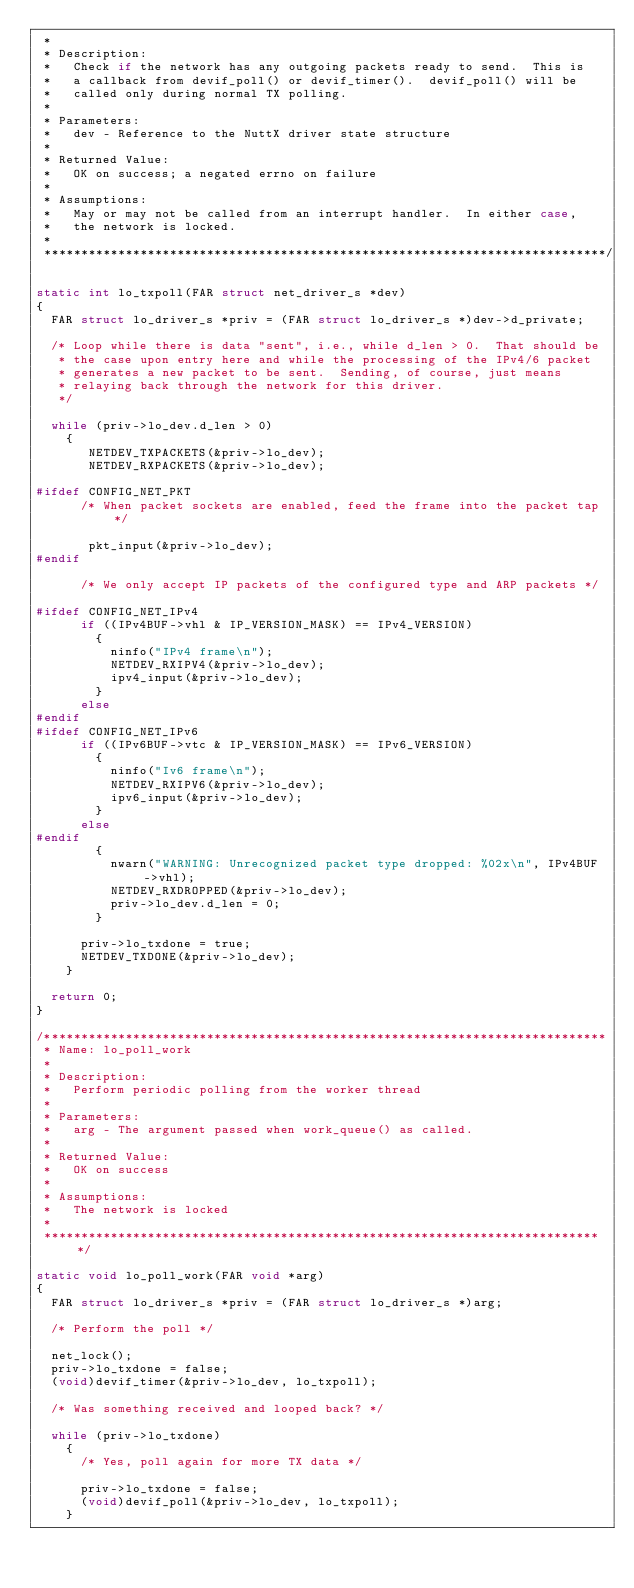<code> <loc_0><loc_0><loc_500><loc_500><_C_> *
 * Description:
 *   Check if the network has any outgoing packets ready to send.  This is
 *   a callback from devif_poll() or devif_timer().  devif_poll() will be
 *   called only during normal TX polling.
 *
 * Parameters:
 *   dev - Reference to the NuttX driver state structure
 *
 * Returned Value:
 *   OK on success; a negated errno on failure
 *
 * Assumptions:
 *   May or may not be called from an interrupt handler.  In either case,
 *   the network is locked.
 *
 ****************************************************************************/

static int lo_txpoll(FAR struct net_driver_s *dev)
{
  FAR struct lo_driver_s *priv = (FAR struct lo_driver_s *)dev->d_private;

  /* Loop while there is data "sent", i.e., while d_len > 0.  That should be
   * the case upon entry here and while the processing of the IPv4/6 packet
   * generates a new packet to be sent.  Sending, of course, just means
   * relaying back through the network for this driver.
   */

  while (priv->lo_dev.d_len > 0)
    {
       NETDEV_TXPACKETS(&priv->lo_dev);
       NETDEV_RXPACKETS(&priv->lo_dev);

#ifdef CONFIG_NET_PKT
      /* When packet sockets are enabled, feed the frame into the packet tap */

       pkt_input(&priv->lo_dev);
#endif

      /* We only accept IP packets of the configured type and ARP packets */

#ifdef CONFIG_NET_IPv4
      if ((IPv4BUF->vhl & IP_VERSION_MASK) == IPv4_VERSION)
        {
          ninfo("IPv4 frame\n");
          NETDEV_RXIPV4(&priv->lo_dev);
          ipv4_input(&priv->lo_dev);
        }
      else
#endif
#ifdef CONFIG_NET_IPv6
      if ((IPv6BUF->vtc & IP_VERSION_MASK) == IPv6_VERSION)
        {
          ninfo("Iv6 frame\n");
          NETDEV_RXIPV6(&priv->lo_dev);
          ipv6_input(&priv->lo_dev);
        }
      else
#endif
        {
          nwarn("WARNING: Unrecognized packet type dropped: %02x\n", IPv4BUF->vhl);
          NETDEV_RXDROPPED(&priv->lo_dev);
          priv->lo_dev.d_len = 0;
        }

      priv->lo_txdone = true;
      NETDEV_TXDONE(&priv->lo_dev);
    }

  return 0;
}

/****************************************************************************
 * Name: lo_poll_work
 *
 * Description:
 *   Perform periodic polling from the worker thread
 *
 * Parameters:
 *   arg - The argument passed when work_queue() as called.
 *
 * Returned Value:
 *   OK on success
 *
 * Assumptions:
 *   The network is locked
 *
 ****************************************************************************/

static void lo_poll_work(FAR void *arg)
{
  FAR struct lo_driver_s *priv = (FAR struct lo_driver_s *)arg;

  /* Perform the poll */

  net_lock();
  priv->lo_txdone = false;
  (void)devif_timer(&priv->lo_dev, lo_txpoll);

  /* Was something received and looped back? */

  while (priv->lo_txdone)
    {
      /* Yes, poll again for more TX data */

      priv->lo_txdone = false;
      (void)devif_poll(&priv->lo_dev, lo_txpoll);
    }
</code> 